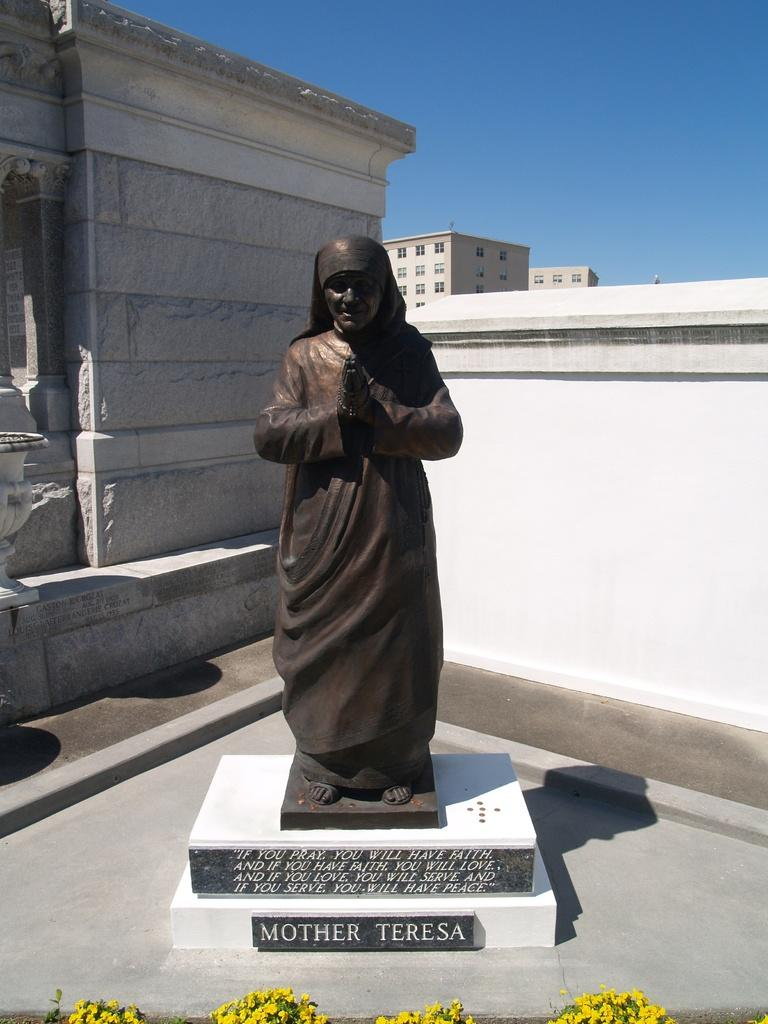What is the main subject in the image? There is a statue in the image. What else can be seen in the background of the image? There are buildings in the image. Are there any inscriptions or text in the image? Yes, there is text on the stones in the image. What type of vegetation is present in the image? There are flowers in the image. What type of grape is being used to create the statue in the image? There is no grape present in the image, and the statue is not made of grapes. 